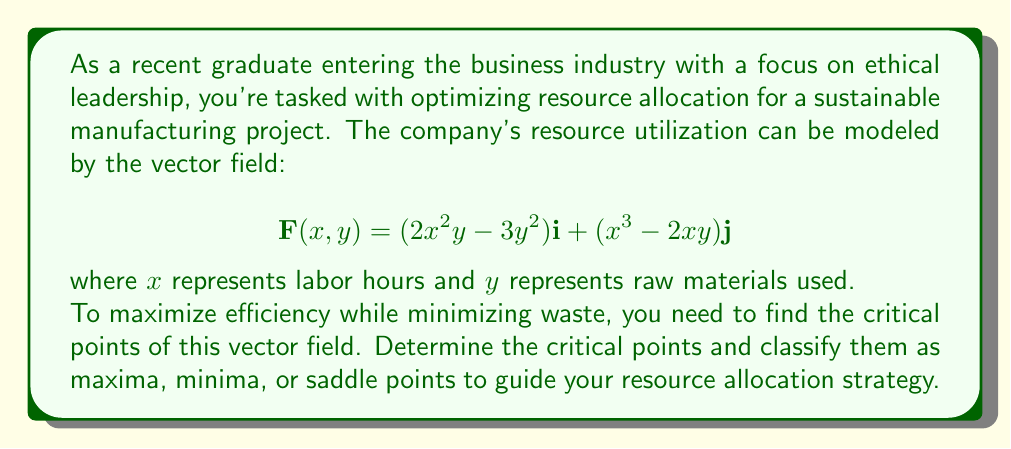Teach me how to tackle this problem. To solve this problem, we'll follow these steps:

1) Find the gradient of the vector field
2) Set the gradient equal to zero and solve for critical points
3) Compute the Hessian matrix
4) Evaluate the Hessian at each critical point to classify them

Step 1: Find the gradient

The gradient of a vector field $\mathbf{F}(x,y) = P(x,y)\mathbf{i} + Q(x,y)\mathbf{j}$ is given by:

$$\nabla \mathbf{F} = \left(\frac{\partial P}{\partial x} + \frac{\partial Q}{\partial y}\right)$$

Here, $P(x,y) = 2x^2y - 3y^2$ and $Q(x,y) = x^3 - 2xy$

$$\frac{\partial P}{\partial x} = 4xy$$
$$\frac{\partial Q}{\partial y} = -2x$$

Therefore, the gradient is:

$$\nabla \mathbf{F} = 4xy - 2x = 2x(2y-1)$$

Step 2: Set gradient to zero and solve

$$2x(2y-1) = 0$$

This is satisfied when $x=0$ or $y=\frac{1}{2}$. When $x=0$, $y$ can be any value. When $y=\frac{1}{2}$, $x$ can be any value except 0.

Critical points: $(0,y)$ for any $y$, and $(x,\frac{1}{2})$ for any $x \neq 0$

Step 3: Compute the Hessian matrix

The Hessian matrix is:

$$H = \begin{bmatrix}
\frac{\partial^2 \mathbf{F}}{\partial x^2} & \frac{\partial^2 \mathbf{F}}{\partial x \partial y} \\
\frac{\partial^2 \mathbf{F}}{\partial y \partial x} & \frac{\partial^2 \mathbf{F}}{\partial y^2}
\end{bmatrix}$$

$$H = \begin{bmatrix}
4y-2 & 4x \\
4x & 0
\end{bmatrix}$$

Step 4: Evaluate Hessian at critical points

For $(0,y)$:
$$H = \begin{bmatrix}
4y-2 & 0 \\
0 & 0
\end{bmatrix}$$

The determinant is always zero, so these are saddle points.

For $(x,\frac{1}{2})$:
$$H = \begin{bmatrix}
0 & 4x \\
4x & 0
\end{bmatrix}$$

The determinant is $-(4x)^2 < 0$ for $x \neq 0$, so these are also saddle points.
Answer: The critical points are:
1) $(0,y)$ for any $y$: These are saddle points.
2) $(x,\frac{1}{2})$ for any $x \neq 0$: These are also saddle points.

There are no local maxima or minima in this vector field, only saddle points. This suggests that the resource allocation strategy should focus on finding a balance between labor hours and raw materials, as any extreme allocation in either direction will not lead to optimal efficiency. 